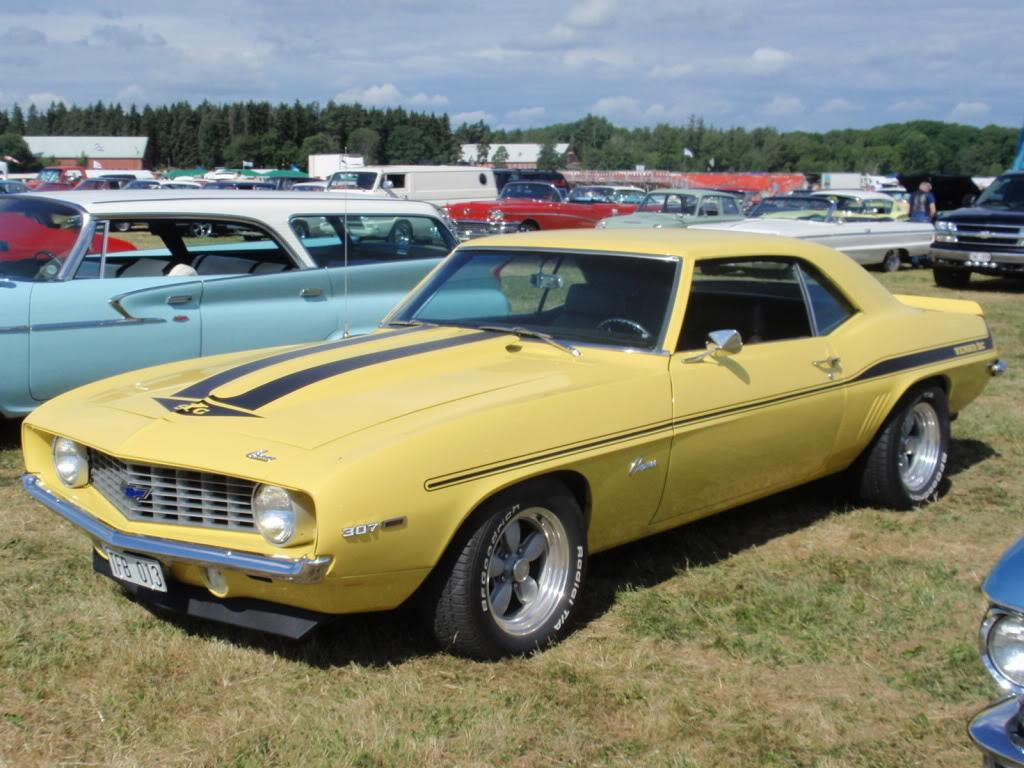What type of vegetation is present in the image? There is grass in the image. What can be seen in terms of vehicles in the image? There are different colors of cars in the image. What is visible in the background of the image? There are trees in the background of the image. What is visible at the top of the image? The sky is visible at the top of the image, and there are clouds in the sky. Who is the owner of the jellyfish in the image? There are no jellyfish present in the image; it features grass, cars, trees, and a sky with clouds. 